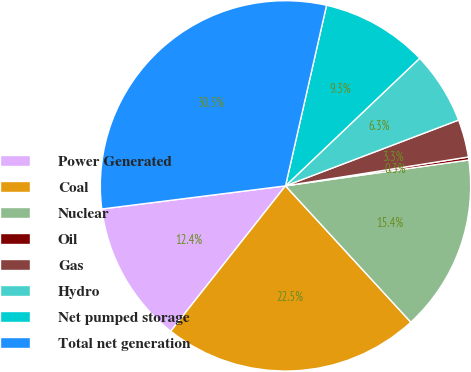Convert chart. <chart><loc_0><loc_0><loc_500><loc_500><pie_chart><fcel>Power Generated<fcel>Coal<fcel>Nuclear<fcel>Oil<fcel>Gas<fcel>Hydro<fcel>Net pumped storage<fcel>Total net generation<nl><fcel>12.37%<fcel>22.47%<fcel>15.4%<fcel>0.26%<fcel>3.29%<fcel>6.32%<fcel>9.34%<fcel>30.55%<nl></chart> 